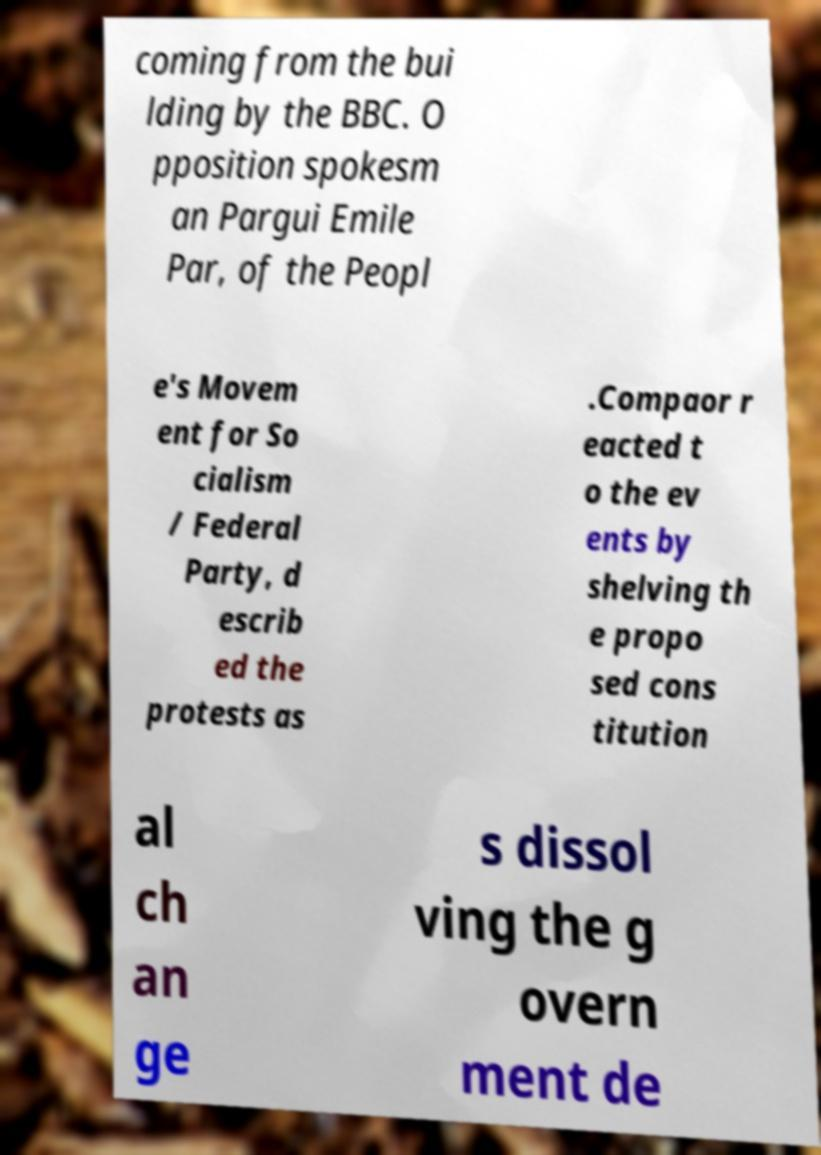Can you read and provide the text displayed in the image?This photo seems to have some interesting text. Can you extract and type it out for me? coming from the bui lding by the BBC. O pposition spokesm an Pargui Emile Par, of the Peopl e's Movem ent for So cialism / Federal Party, d escrib ed the protests as .Compaor r eacted t o the ev ents by shelving th e propo sed cons titution al ch an ge s dissol ving the g overn ment de 